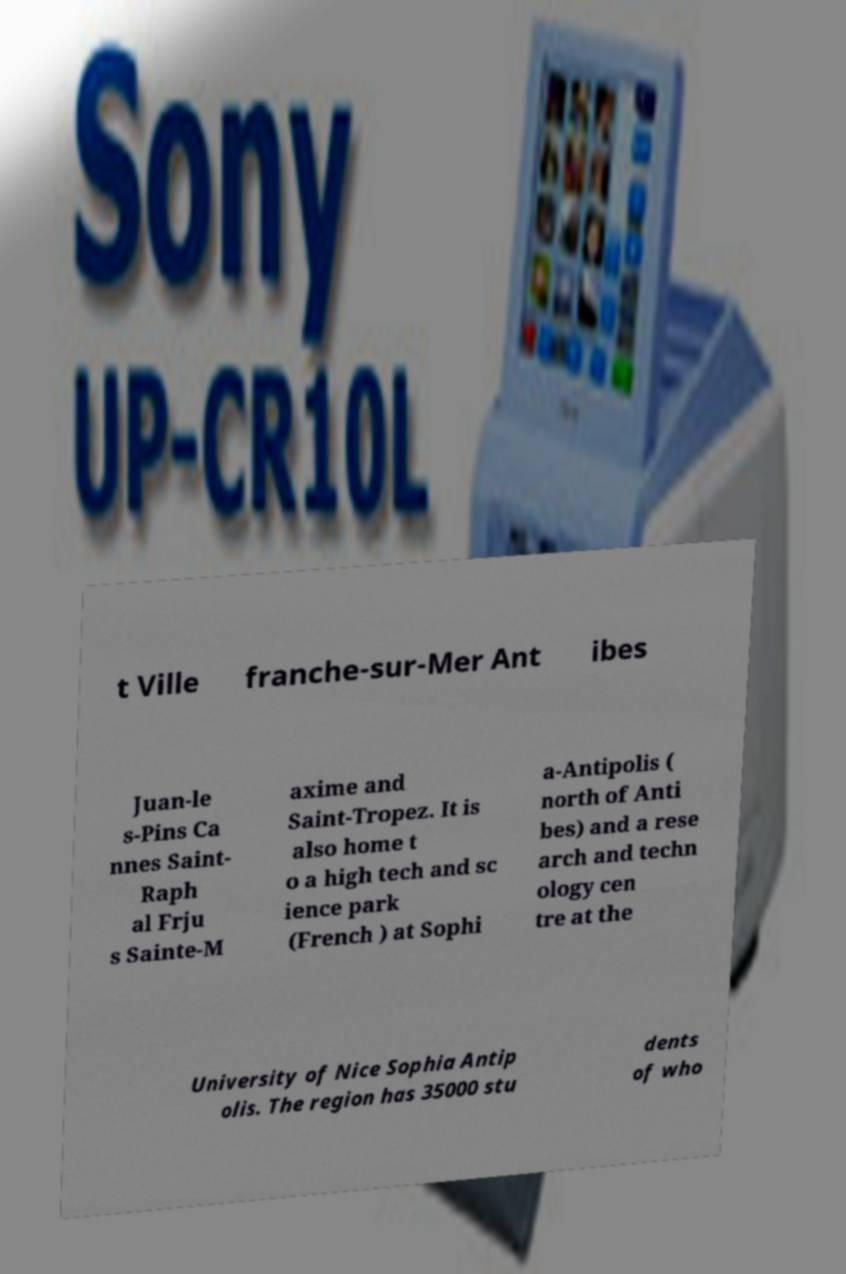What messages or text are displayed in this image? I need them in a readable, typed format. t Ville franche-sur-Mer Ant ibes Juan-le s-Pins Ca nnes Saint- Raph al Frju s Sainte-M axime and Saint-Tropez. It is also home t o a high tech and sc ience park (French ) at Sophi a-Antipolis ( north of Anti bes) and a rese arch and techn ology cen tre at the University of Nice Sophia Antip olis. The region has 35000 stu dents of who 